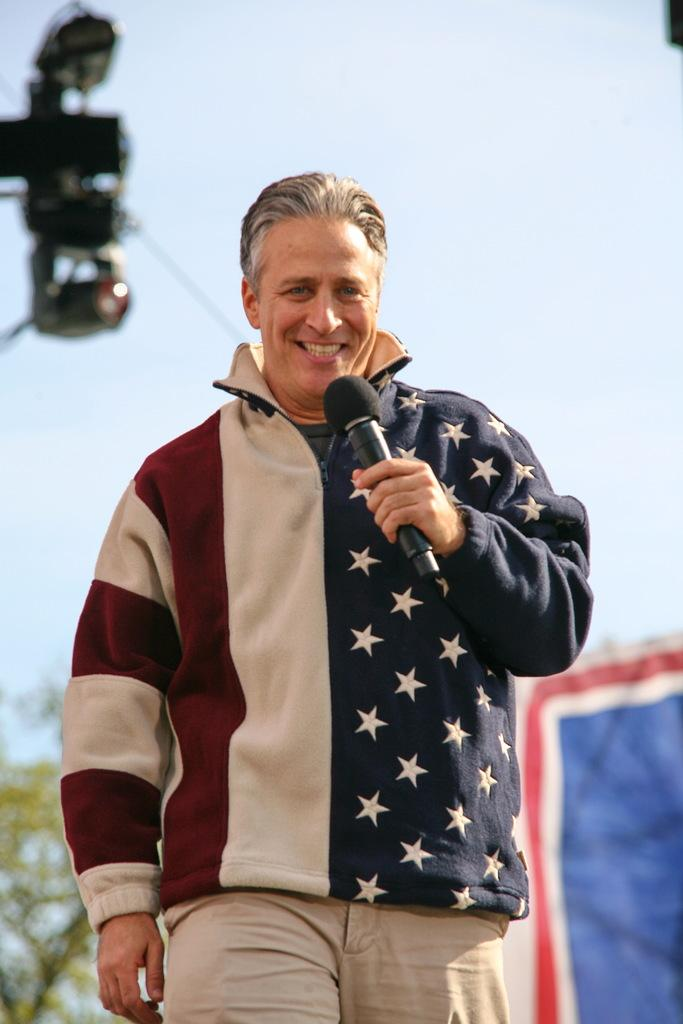What is the main subject of the image? There is a man in the image. What is the man doing in the image? The man is standing and holding a microphone. What is the man's facial expression in the image? The man is smiling in the image. What can be seen in the background of the image? There is a tree, a curtain, and the sky visible in the background of the image. How many ants can be seen crawling on the microphone in the image? There are no ants visible on the microphone in the image. What type of bean is present in the image? There is no bean present in the image. 